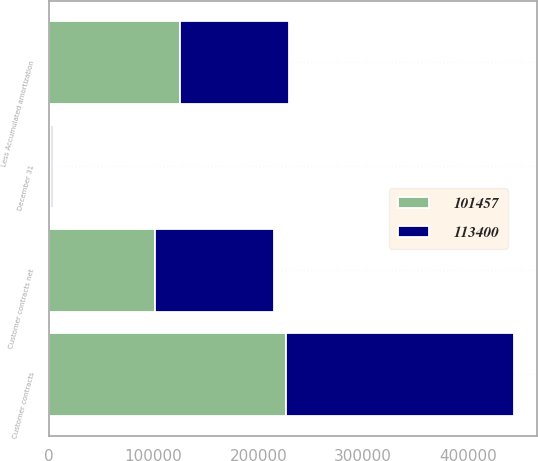Convert chart. <chart><loc_0><loc_0><loc_500><loc_500><stacked_bar_chart><ecel><fcel>December 31<fcel>Customer contracts<fcel>Less Accumulated amortization<fcel>Customer contracts net<nl><fcel>101457<fcel>2013<fcel>226717<fcel>125260<fcel>101457<nl><fcel>113400<fcel>2012<fcel>217384<fcel>103984<fcel>113400<nl></chart> 